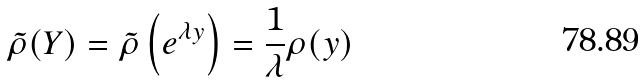Convert formula to latex. <formula><loc_0><loc_0><loc_500><loc_500>\tilde { \rho } ( Y ) = \tilde { \rho } \left ( e ^ { \lambda y } \right ) = \frac { 1 } { \lambda } \rho ( y )</formula> 